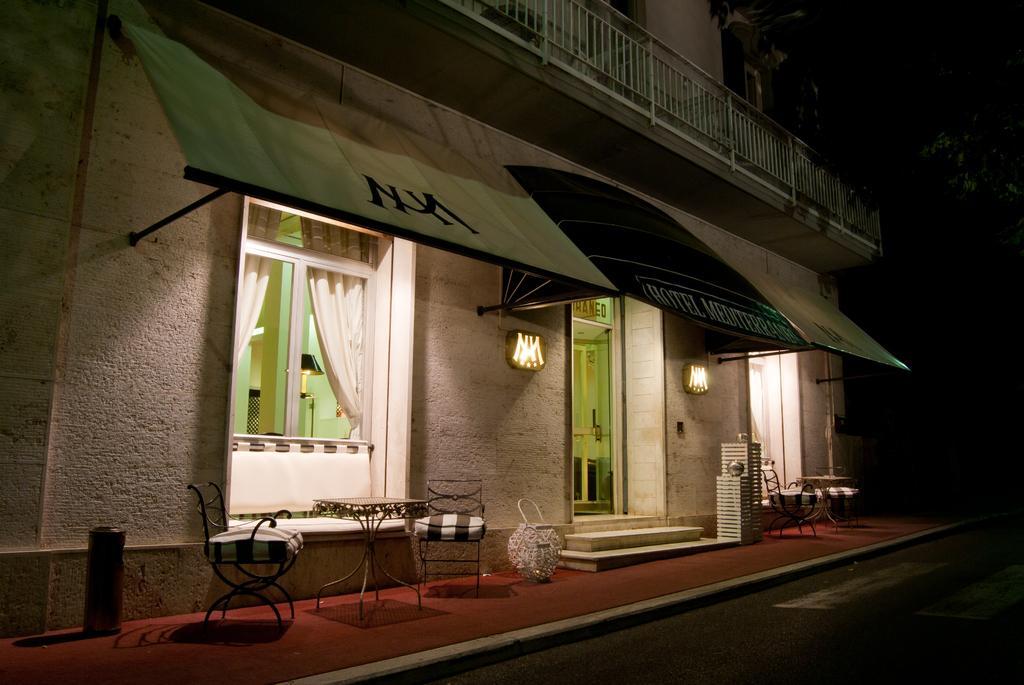Please provide a concise description of this image. In this image in the center there is one building and windows and doors, at the bottom there are tables and chairs and some other objects. On the right side there are some trees, at the bottom there is a walkway. 